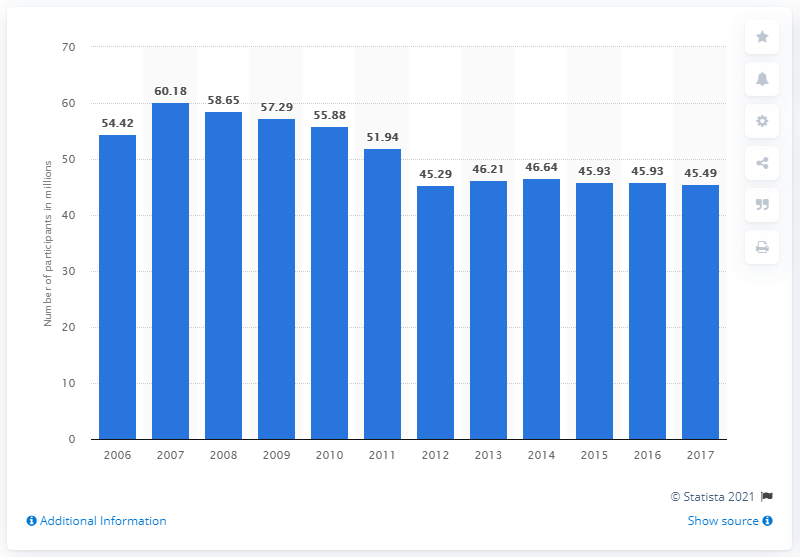Mention a couple of crucial points in this snapshot. In 2017, the total number of participants in bowling in the United States was 45,490. 